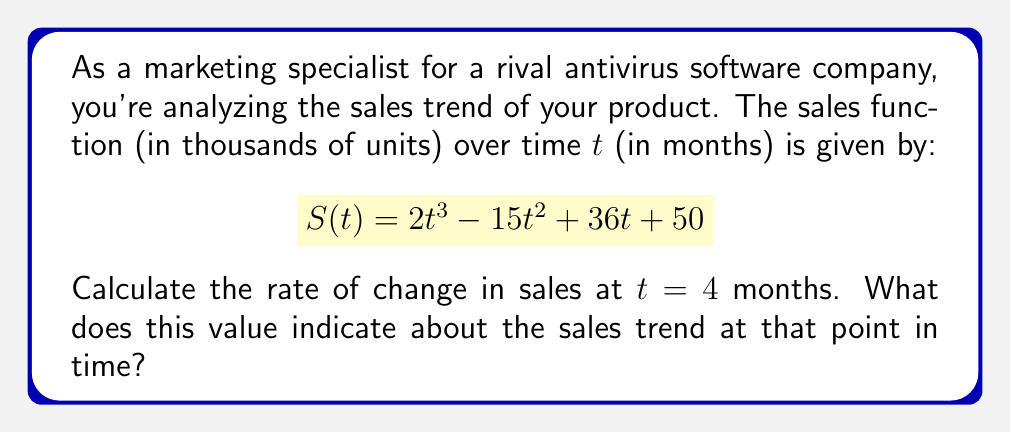Solve this math problem. To solve this problem, we need to follow these steps:

1) The rate of change in sales is represented by the derivative of the sales function. Let's call this $S'(t)$.

2) To find $S'(t)$, we need to differentiate $S(t)$ with respect to $t$:

   $$S'(t) = \frac{d}{dt}(2t^3 - 15t^2 + 36t + 50)$$

3) Using the power rule and constant rule of differentiation:

   $$S'(t) = 6t^2 - 30t + 36$$

4) Now, we need to find the value of $S'(t)$ at $t = 4$:

   $$S'(4) = 6(4)^2 - 30(4) + 36$$
   $$= 6(16) - 120 + 36$$
   $$= 96 - 120 + 36$$
   $$= 12$$

5) Interpreting the result:
   The rate of change at $t = 4$ is 12, which means that at 4 months, the sales are increasing at a rate of 12,000 units per month.
Answer: 12 thousand units/month (increasing) 